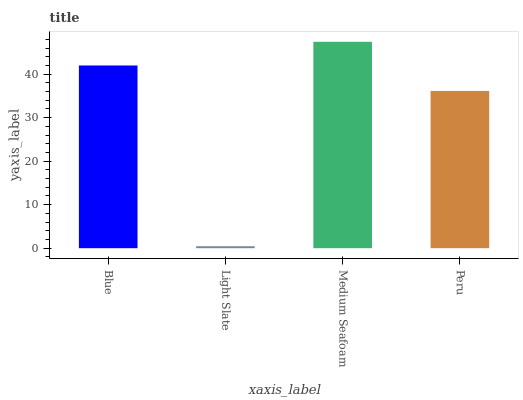Is Light Slate the minimum?
Answer yes or no. Yes. Is Medium Seafoam the maximum?
Answer yes or no. Yes. Is Medium Seafoam the minimum?
Answer yes or no. No. Is Light Slate the maximum?
Answer yes or no. No. Is Medium Seafoam greater than Light Slate?
Answer yes or no. Yes. Is Light Slate less than Medium Seafoam?
Answer yes or no. Yes. Is Light Slate greater than Medium Seafoam?
Answer yes or no. No. Is Medium Seafoam less than Light Slate?
Answer yes or no. No. Is Blue the high median?
Answer yes or no. Yes. Is Peru the low median?
Answer yes or no. Yes. Is Light Slate the high median?
Answer yes or no. No. Is Medium Seafoam the low median?
Answer yes or no. No. 